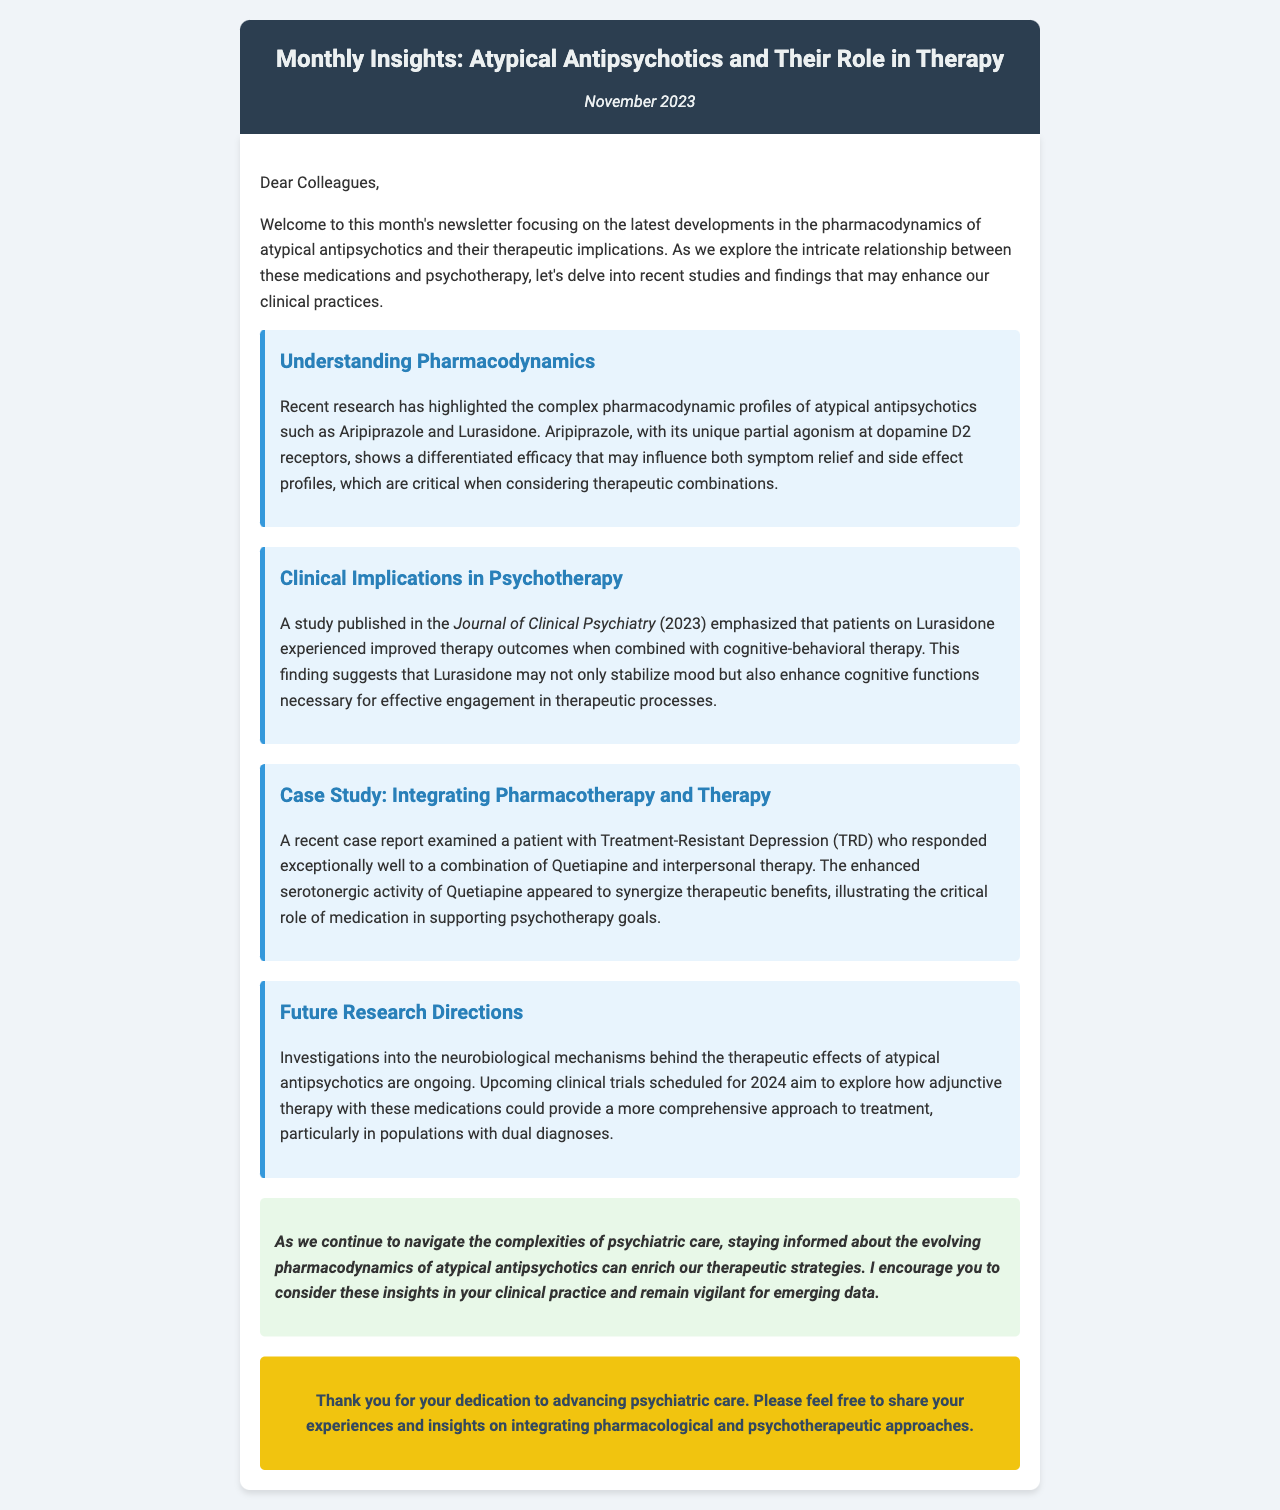What is the title of the newsletter? The title is prominently displayed at the top of the document.
Answer: Monthly Insights: Atypical Antipsychotics and Their Role in Therapy What is the date of the newsletter? The date is mentioned right below the title in the header section.
Answer: November 2023 Which atypical antipsychotic is mentioned for its partial agonism at dopamine D2 receptors? This is a specific characteristic highlighted in the pharmacodynamics section.
Answer: Aripiprazole What therapy was found to enhance outcomes for patients on Lurasidone? This is stated in the clinical implications section as part of the findings from a study.
Answer: Cognitive-behavioral therapy What condition was a patient diagnosed with in the case study? The document specifically mentions a diagnosis in relation to the case study discussed.
Answer: Treatment-Resistant Depression Which publication is cited for the study on Lurasidone and cognitive-behavioral therapy? The source is given in the clinical implications section of the newsletter.
Answer: Journal of Clinical Psychiatry What is the upcoming focus of future research mentioned? This is detailed in the future research directions section of the document.
Answer: Neurobiological mechanisms What is the main theme of the newsletter? The opening paragraph encapsulates the main focus of the document.
Answer: Pharmacodynamics of atypical antipsychotics 